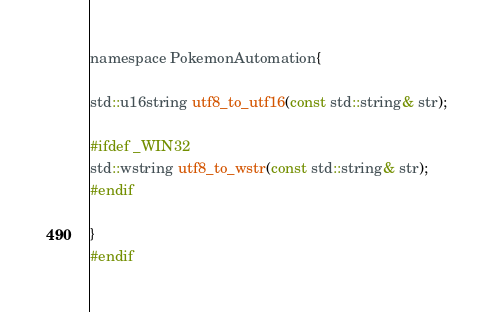<code> <loc_0><loc_0><loc_500><loc_500><_C_>namespace PokemonAutomation{

std::u16string utf8_to_utf16(const std::string& str);

#ifdef _WIN32
std::wstring utf8_to_wstr(const std::string& str);
#endif

}
#endif
</code> 